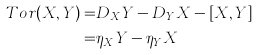Convert formula to latex. <formula><loc_0><loc_0><loc_500><loc_500>T o r ( X , Y ) = & D _ { X } Y - D _ { Y } X - [ X , Y ] \\ = & \eta _ { X } Y - \eta _ { Y } X</formula> 